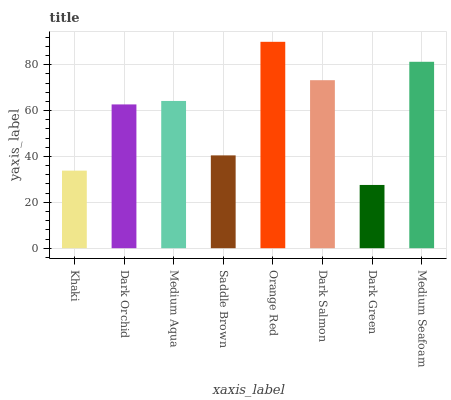Is Dark Orchid the minimum?
Answer yes or no. No. Is Dark Orchid the maximum?
Answer yes or no. No. Is Dark Orchid greater than Khaki?
Answer yes or no. Yes. Is Khaki less than Dark Orchid?
Answer yes or no. Yes. Is Khaki greater than Dark Orchid?
Answer yes or no. No. Is Dark Orchid less than Khaki?
Answer yes or no. No. Is Medium Aqua the high median?
Answer yes or no. Yes. Is Dark Orchid the low median?
Answer yes or no. Yes. Is Dark Orchid the high median?
Answer yes or no. No. Is Dark Green the low median?
Answer yes or no. No. 